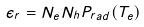<formula> <loc_0><loc_0><loc_500><loc_500>\epsilon _ { r } = N _ { e } N _ { h } P _ { r a d } ( T _ { e } )</formula> 